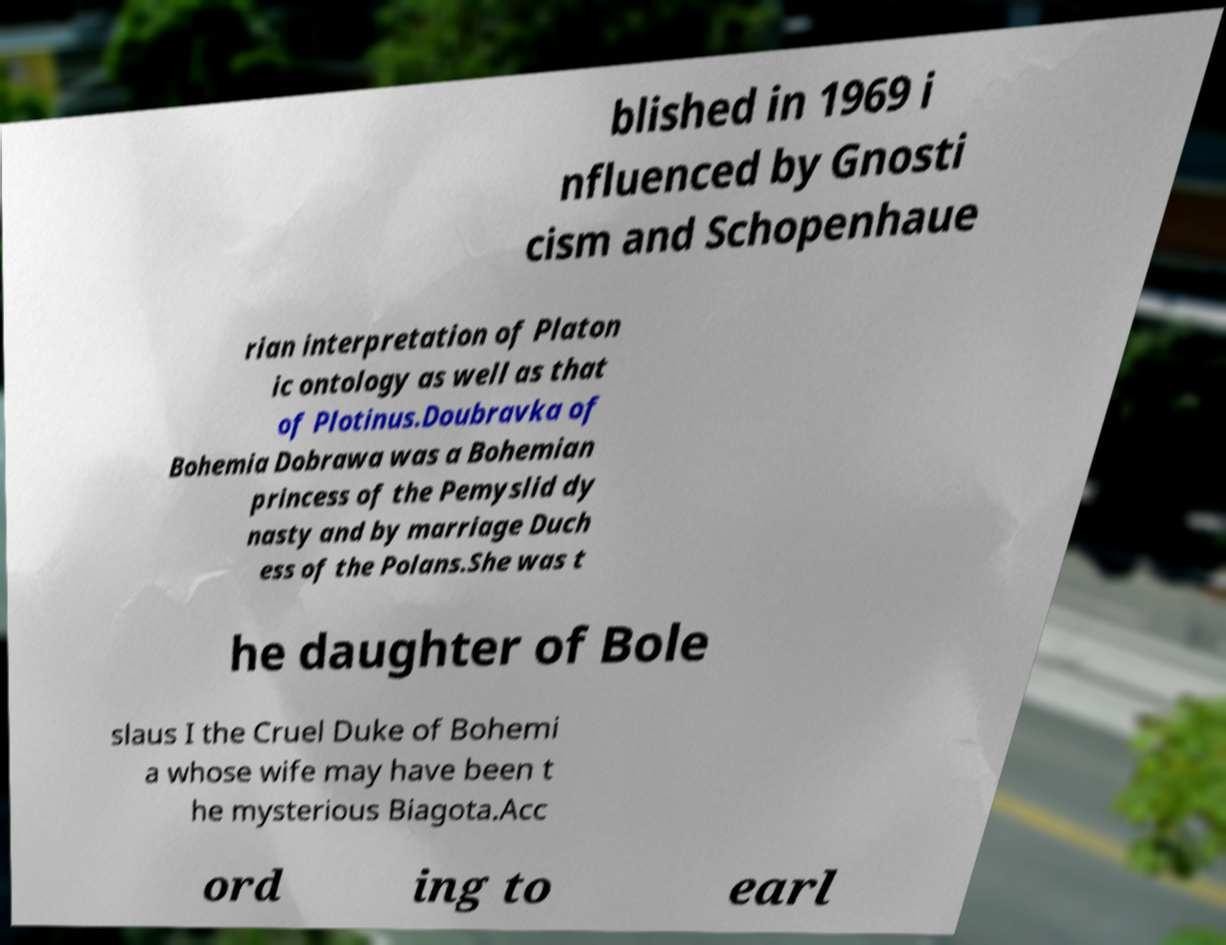Can you read and provide the text displayed in the image?This photo seems to have some interesting text. Can you extract and type it out for me? blished in 1969 i nfluenced by Gnosti cism and Schopenhaue rian interpretation of Platon ic ontology as well as that of Plotinus.Doubravka of Bohemia Dobrawa was a Bohemian princess of the Pemyslid dy nasty and by marriage Duch ess of the Polans.She was t he daughter of Bole slaus I the Cruel Duke of Bohemi a whose wife may have been t he mysterious Biagota.Acc ord ing to earl 